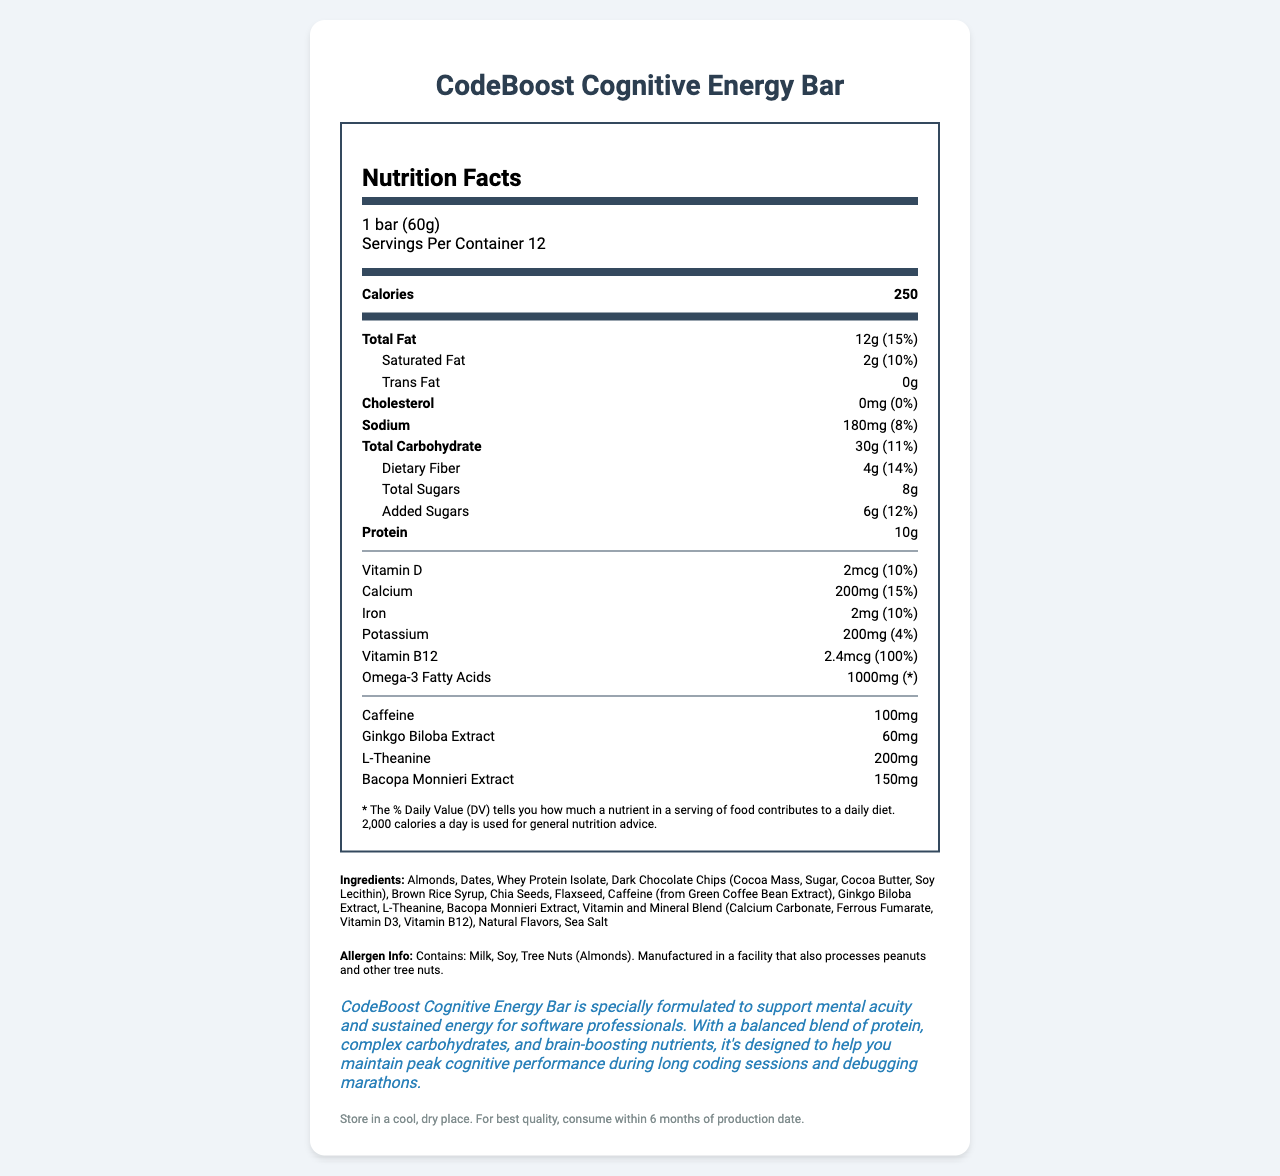what is the product name? The product name is clearly stated at the beginning of the document and highlighted as the title.
Answer: CodeBoost Cognitive Energy Bar what is the serving size? The serving size information is included right after the title under the serving info section.
Answer: 1 bar (60g) how many servings are in a container? The number of servings per container is listed next to the serving size under the serving info section.
Answer: 12 how many calories are in one serving? The amount of calories per serving is prominently displayed in bold near the top of the nutrition label.
Answer: 250 how much caffeine does one bar contain? The amount of caffeine per serving is listed at the bottom in the nutrient section.
Answer: 100mg does the product contain any trans fat? The document specifies that the trans fat content is 0g.
Answer: No which of the following nutrients has the highest percentage of daily value? A. Iron B. Vitamin D C. Vitamin B12 D. Calcium The daily value for Vitamin B12 is 100%, which is the highest among the listed options.
Answer: C. Vitamin B12 which of the following ingredients is not listed in the energy bar? A. Almonds B. Dates C. Sugar D. Peanuts Peanuts are mentioned in the allergen info as a potential cross-contaminant but are not listed as an ingredient.
Answer: D. Peanuts is the product designed to support cognitive function? The health claim explicitly states that the product is formulated to support mental acuity and cognitive performance.
Answer: Yes summarize the document. The document provides comprehensive information on the CodeBoost Cognitive Energy Bar, including its target demographics, nutritional content, and cognitive health benefits. It is designed to help maintain peak cognitive performance during demanding tasks.
Answer: The document is a detailed description of the CodeBoost Cognitive Energy Bar, emphasizing its formulation for supporting cognitive function. It includes nutritional information, ingredients, allergen info, health claims, and storage instructions. Specific nutrients like Vitamin B12 and cognitive enhancers like caffeine and Ginkgo Biloba Extract are highlighted to underline the product's benefits for software professionals. what are the protein sources mentioned in the ingredients? The ingredients list mentions Whey Protein Isolate and Almonds as the protein sources.
Answer: Whey Protein Isolate, Almonds how much dietary fiber is in one serving, and what percentage of the daily value does it represent? The document states that each serving contains 4g of dietary fiber, which is 14% of the daily value.
Answer: 4g, 14% what is the amount of Bacopa Monnieri Extract in the bar? The amount of Bacopa Monnieri Extract is listed in the nutrient section.
Answer: 150mg which vitamins and minerals are included in the vitamin and mineral blend? A. Vitamin C, Calcium, Iron B. Calcium, Iron, Vitamin D3, Vitamin B12 C. Vitamin A, Iron, Potassium The vitamin and mineral blend listed in the ingredients section includes Calcium, Iron, Vitamin D3, and Vitamin B12.
Answer: B. Calcium, Iron, Vitamin D3, Vitamin B12 what is the storage instruction for the product? The storage instructions are clearly listed at the end of the document.
Answer: Store in a cool, dry place. For best quality, consume within 6 months of production date. how much Omega-3 fatty acids does one bar contain? The Omega-3 fatty acid content is specified in the nutrient section.
Answer: 1000mg is there any information on how the product tastes? The document does not provide any information about the taste of the product; it only lists nutritional content and health benefits.
Answer: Cannot be determined what is the total amount of sugars in one bar? The total sugar content is 8g, as stated in the nutrient section.
Answer: 8g what percentage of the daily value for calcium does one serving provide? The calcium content per serving is 15% of the daily value.
Answer: 15% what is the health claim made by the product? The health claim is prominently displayed and emphasizes cognitive support and energy maintenance for software professionals.
Answer: CodeBoost Cognitive Energy Bar is specially formulated to support mental acuity and sustained energy for software professionals. 